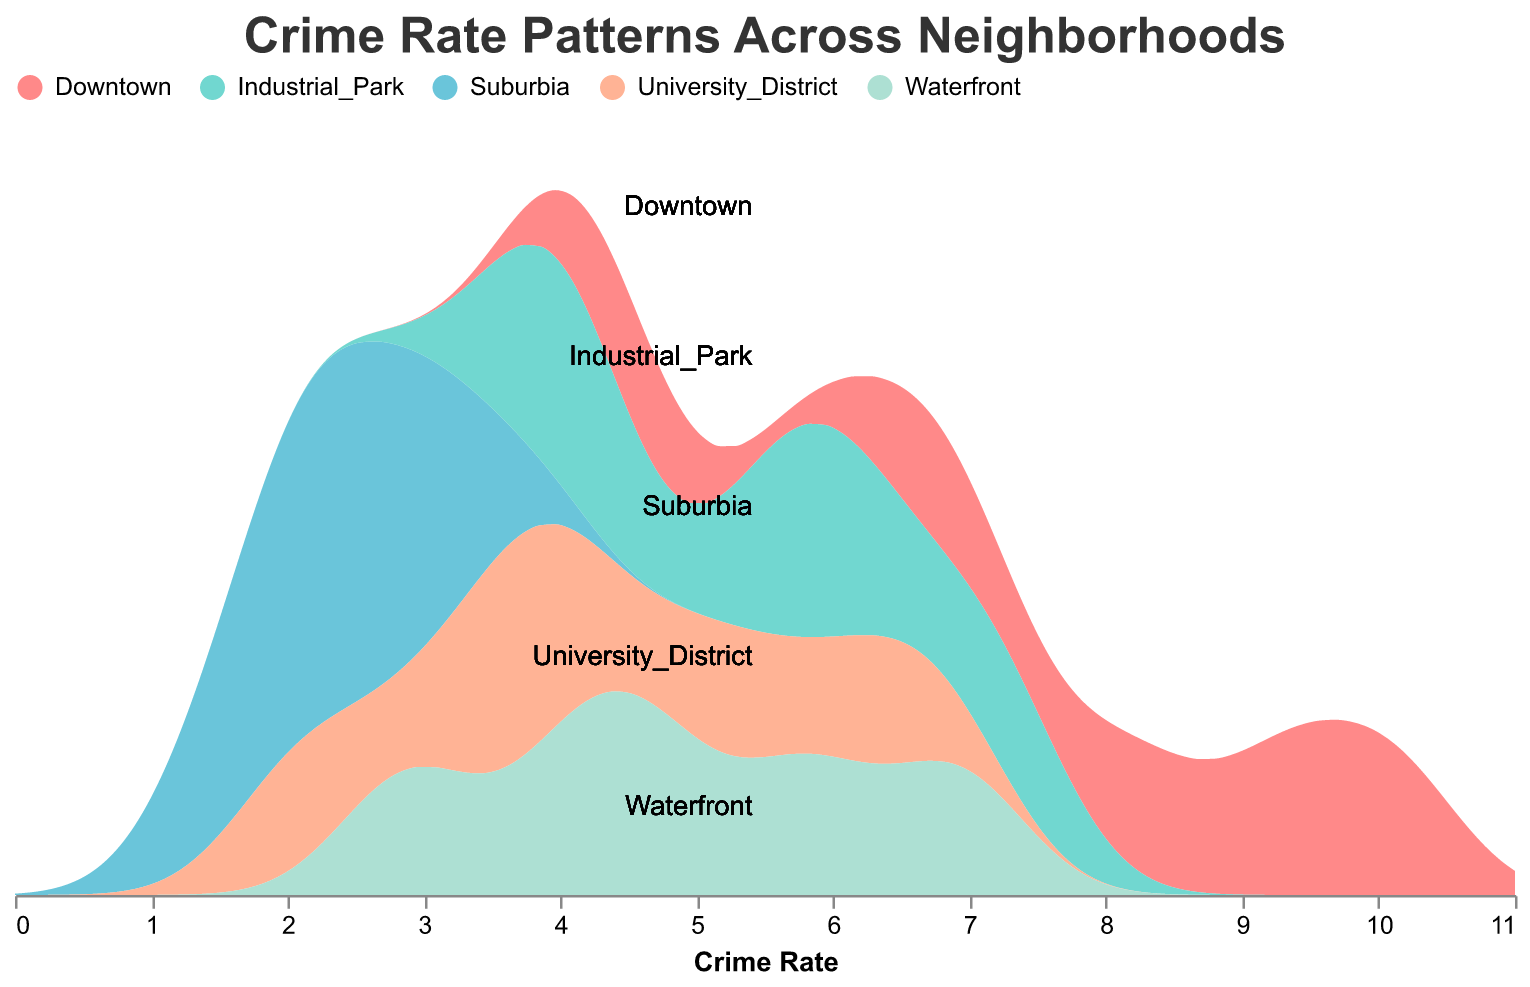What is the title of the chart? The title is written at the top of the chart in bold and larger font compared to other text in the chart.
Answer: Crime Rate Patterns Across Neighborhoods How many neighborhoods are compared in the chart? The chart contains areas labeled by different colors and rows, and there are five distinct neighborhoods listed.
Answer: Five Which neighborhood has the highest crime rate at hour 23? By looking at the crime rates for hour 23 in each neighborhood's row and identifying the highest one, you see that Downtown has the highest crime rate.
Answer: Downtown What is the crime rate trend for Suburbia over the 24-hour period? By observing the crime rates in Suburbia's row from hour 0 to hour 23, we see that crime rates remain low, with a slight increase towards the evening, peaking at hour 18.
Answer: Low throughout, slight peak at hour 18 Compare the crime rates of Downtown and Waterfront at hour 0. Which neighborhood has a higher crime rate? Look at the numbers corresponding to hour 0 for both Downtown and Waterfront. Downtown has a crime rate of 8.2, while Waterfront has a rate of 4.7. Downtown has the higher crime rate.
Answer: Downtown What is the general trend of crime rates in the Industrial Park over the 24-hour period? By examining the crime rates in the Industrial Park's row across different hours, you can see the crime rates decrease by hour 6, then gradually increase, peaking at hour 23.
Answer: Decrease then increase What are the average crime rates for University District at hour 12 and hour 18? Sum the crime rates for University District at hour 12 and hour 18 and divide by 2: (3.5 + 5.2)/2 = 8.7/2 = 4.35.
Answer: 4.35 Which neighborhood has the least fluctuation in crime rates throughout the day? Compare the differences between minimum and maximum crime rates for each neighborhood across the different hours. Suburbia has the smallest range.
Answer: Suburbia How do the crime rates in Downtown compare to those in Industrial Park at hour 6 and hour 18? At hour 6, Downtown has a crime rate of 4.5, and Industrial Park has 3.8. At hour 18, Downtown has 9.3, and Industrial Park has 6.1. In both hours, Downtown's crime rates are higher.
Answer: Downtown has higher rates What is the maximum crime rate observed in the Waterfront neighborhood over the given hours? By scanning the crime rates for Waterfront, the highest value observed is at hour 23, which is 6.9.
Answer: 6.9 